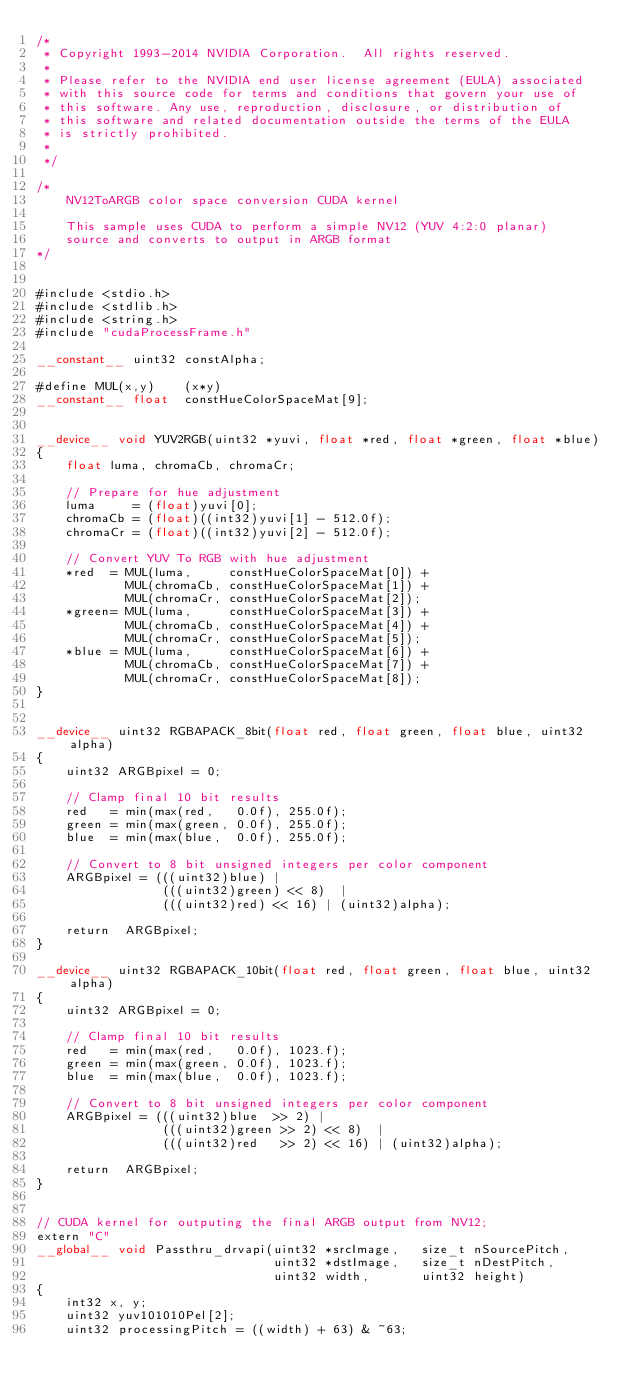<code> <loc_0><loc_0><loc_500><loc_500><_Cuda_>/*
 * Copyright 1993-2014 NVIDIA Corporation.  All rights reserved.
 *
 * Please refer to the NVIDIA end user license agreement (EULA) associated
 * with this source code for terms and conditions that govern your use of
 * this software. Any use, reproduction, disclosure, or distribution of
 * this software and related documentation outside the terms of the EULA
 * is strictly prohibited.
 *
 */

/*
    NV12ToARGB color space conversion CUDA kernel

    This sample uses CUDA to perform a simple NV12 (YUV 4:2:0 planar)
    source and converts to output in ARGB format
*/


#include <stdio.h>
#include <stdlib.h>
#include <string.h>
#include "cudaProcessFrame.h"

__constant__ uint32 constAlpha;

#define MUL(x,y)    (x*y)
__constant__ float  constHueColorSpaceMat[9];


__device__ void YUV2RGB(uint32 *yuvi, float *red, float *green, float *blue)
{
    float luma, chromaCb, chromaCr;

    // Prepare for hue adjustment
    luma     = (float)yuvi[0];
    chromaCb = (float)((int32)yuvi[1] - 512.0f);
    chromaCr = (float)((int32)yuvi[2] - 512.0f);

    // Convert YUV To RGB with hue adjustment
    *red  = MUL(luma,     constHueColorSpaceMat[0]) +
            MUL(chromaCb, constHueColorSpaceMat[1]) +
            MUL(chromaCr, constHueColorSpaceMat[2]);
    *green= MUL(luma,     constHueColorSpaceMat[3]) +
            MUL(chromaCb, constHueColorSpaceMat[4]) +
            MUL(chromaCr, constHueColorSpaceMat[5]);
    *blue = MUL(luma,     constHueColorSpaceMat[6]) +
            MUL(chromaCb, constHueColorSpaceMat[7]) +
            MUL(chromaCr, constHueColorSpaceMat[8]);
}


__device__ uint32 RGBAPACK_8bit(float red, float green, float blue, uint32 alpha)
{
    uint32 ARGBpixel = 0;

    // Clamp final 10 bit results
    red   = min(max(red,   0.0f), 255.0f);
    green = min(max(green, 0.0f), 255.0f);
    blue  = min(max(blue,  0.0f), 255.0f);

    // Convert to 8 bit unsigned integers per color component
    ARGBpixel = (((uint32)blue) |
                 (((uint32)green) << 8)  |
                 (((uint32)red) << 16) | (uint32)alpha);

    return  ARGBpixel;
}

__device__ uint32 RGBAPACK_10bit(float red, float green, float blue, uint32 alpha)
{
    uint32 ARGBpixel = 0;

    // Clamp final 10 bit results
    red   = min(max(red,   0.0f), 1023.f);
    green = min(max(green, 0.0f), 1023.f);
    blue  = min(max(blue,  0.0f), 1023.f);

    // Convert to 8 bit unsigned integers per color component
    ARGBpixel = (((uint32)blue  >> 2) |
                 (((uint32)green >> 2) << 8)  |
                 (((uint32)red   >> 2) << 16) | (uint32)alpha);

    return  ARGBpixel;
}


// CUDA kernel for outputing the final ARGB output from NV12;
extern "C"
__global__ void Passthru_drvapi(uint32 *srcImage,   size_t nSourcePitch,
                                uint32 *dstImage,   size_t nDestPitch,
                                uint32 width,       uint32 height)
{
    int32 x, y;
    uint32 yuv101010Pel[2];
    uint32 processingPitch = ((width) + 63) & ~63;</code> 